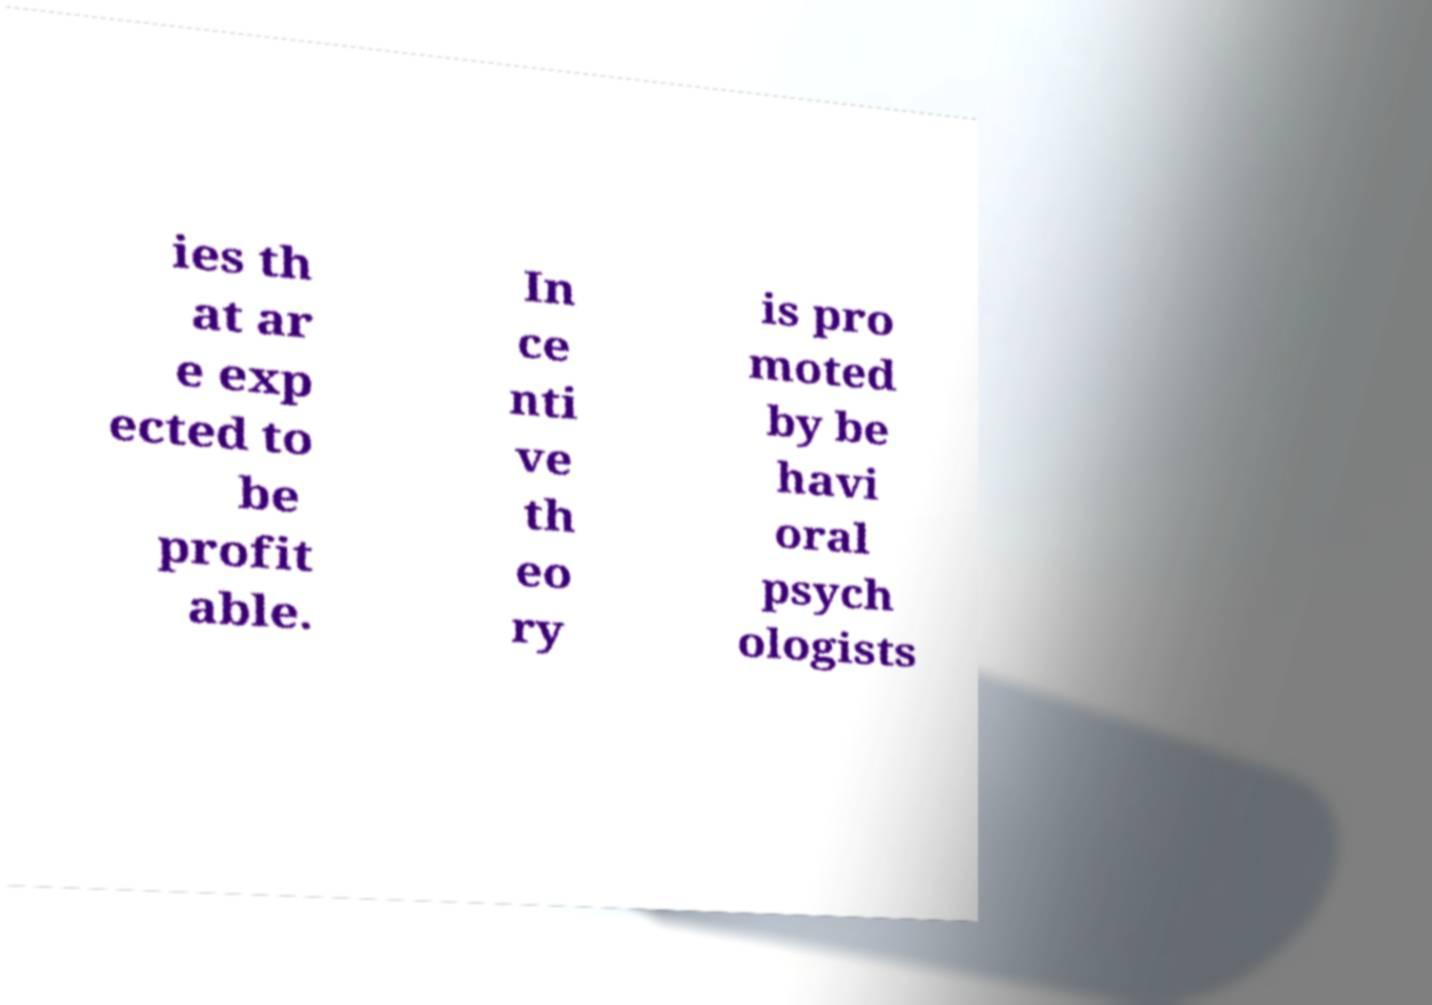Can you read and provide the text displayed in the image?This photo seems to have some interesting text. Can you extract and type it out for me? ies th at ar e exp ected to be profit able. In ce nti ve th eo ry is pro moted by be havi oral psych ologists 